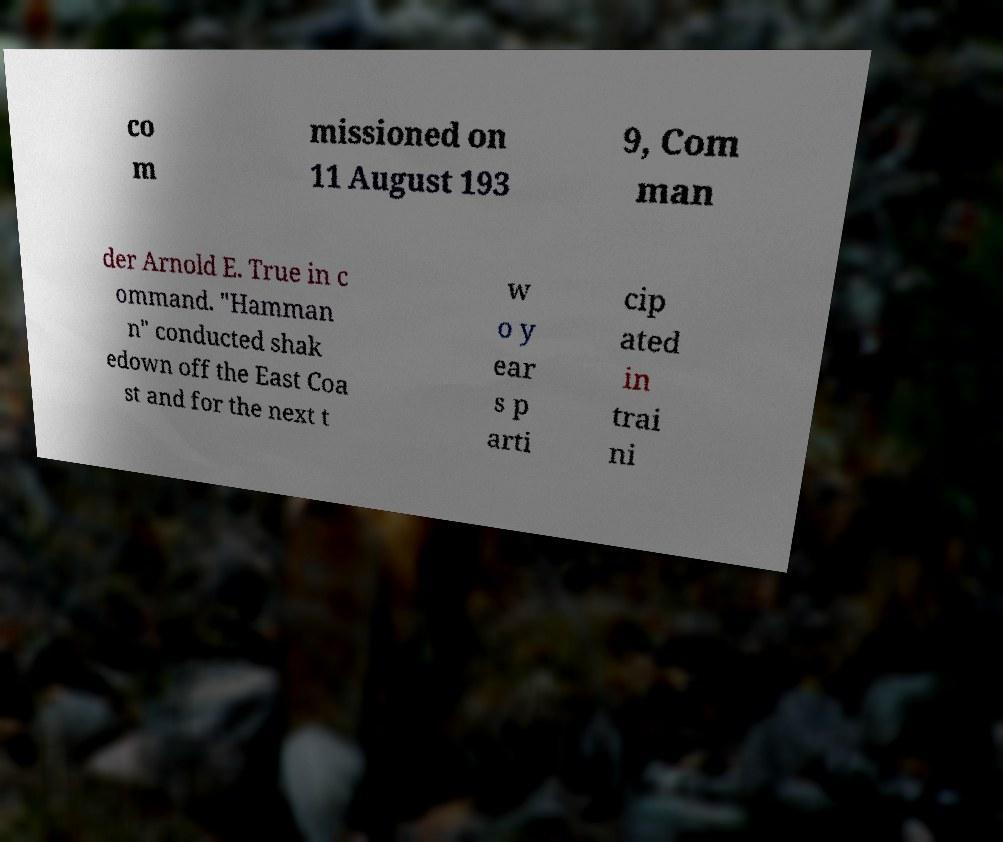Can you read and provide the text displayed in the image?This photo seems to have some interesting text. Can you extract and type it out for me? co m missioned on 11 August 193 9, Com man der Arnold E. True in c ommand. "Hamman n" conducted shak edown off the East Coa st and for the next t w o y ear s p arti cip ated in trai ni 